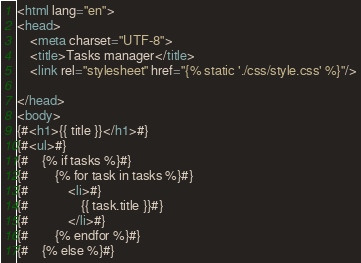<code> <loc_0><loc_0><loc_500><loc_500><_HTML_><html lang="en">
<head>
    <meta charset="UTF-8">
    <title>Tasks manager</title>
    <link rel="stylesheet" href="{% static './css/style.css' %}"/>

</head>
<body>
{#<h1>{{ title }}</h1>#}
{#<ul>#}
{#    {% if tasks %}#}
{#        {% for task in tasks %}#}
{#            <li>#}
{#                {{ task.title }}#}
{#            </li>#}
{#        {% endfor %}#}
{#    {% else %}#}</code> 